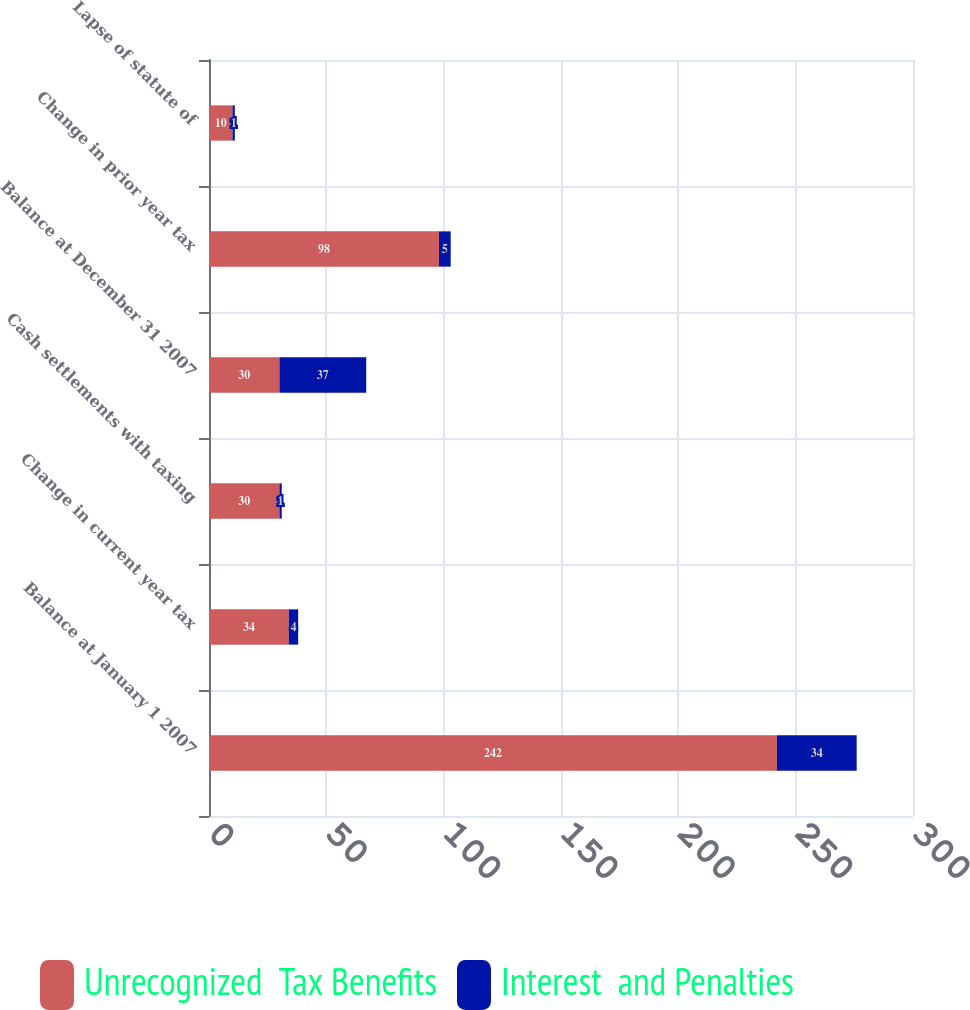Convert chart. <chart><loc_0><loc_0><loc_500><loc_500><stacked_bar_chart><ecel><fcel>Balance at January 1 2007<fcel>Change in current year tax<fcel>Cash settlements with taxing<fcel>Balance at December 31 2007<fcel>Change in prior year tax<fcel>Lapse of statute of<nl><fcel>Unrecognized  Tax Benefits<fcel>242<fcel>34<fcel>30<fcel>30<fcel>98<fcel>10<nl><fcel>Interest  and Penalties<fcel>34<fcel>4<fcel>1<fcel>37<fcel>5<fcel>1<nl></chart> 